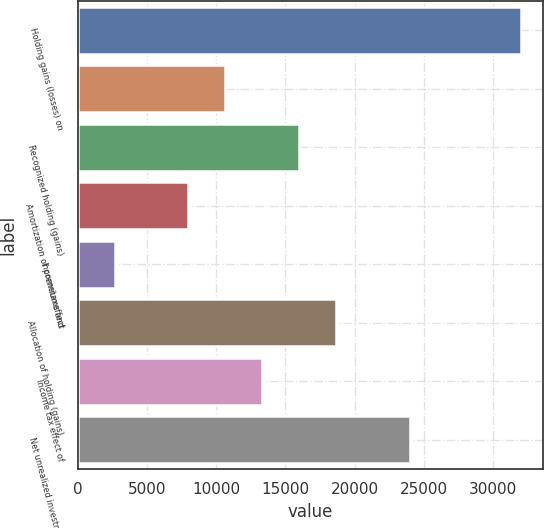Convert chart. <chart><loc_0><loc_0><loc_500><loc_500><bar_chart><fcel>Holding gains (losses) on<fcel>Unnamed: 1<fcel>Recognized holding (gains)<fcel>Amortization of premiums and<fcel>Incometaxeffect<fcel>Allocation of holding (gains)<fcel>Income tax effect of<fcel>Net unrealized investment<nl><fcel>31978<fcel>10666<fcel>15994<fcel>8002<fcel>2674<fcel>18658<fcel>13330<fcel>23986<nl></chart> 